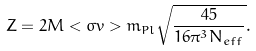Convert formula to latex. <formula><loc_0><loc_0><loc_500><loc_500>Z = 2 M < \sigma v > m _ { P l } \sqrt { \frac { 4 5 } { 1 6 \pi ^ { 3 } N _ { e f f } } } .</formula> 